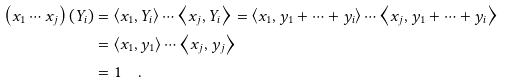<formula> <loc_0><loc_0><loc_500><loc_500>\left ( x _ { 1 } \cdots x _ { j } \right ) \left ( Y _ { i } \right ) & = \left \langle x _ { 1 } , Y _ { i } \right \rangle \cdots \left \langle x _ { j } , Y _ { i } \right \rangle = \left \langle x _ { 1 } , y _ { 1 } + \cdots + y _ { i } \right \rangle \cdots \left \langle x _ { j } , y _ { 1 } + \cdots + y _ { i } \right \rangle \\ & = \left \langle x _ { 1 } , y _ { 1 } \right \rangle \cdots \left \langle x _ { j } , y _ { j } \right \rangle \\ & = 1 \quad .</formula> 